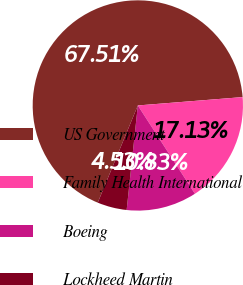<chart> <loc_0><loc_0><loc_500><loc_500><pie_chart><fcel>US Government<fcel>Family Health International<fcel>Boeing<fcel>Lockheed Martin<nl><fcel>67.5%<fcel>17.13%<fcel>10.83%<fcel>4.53%<nl></chart> 